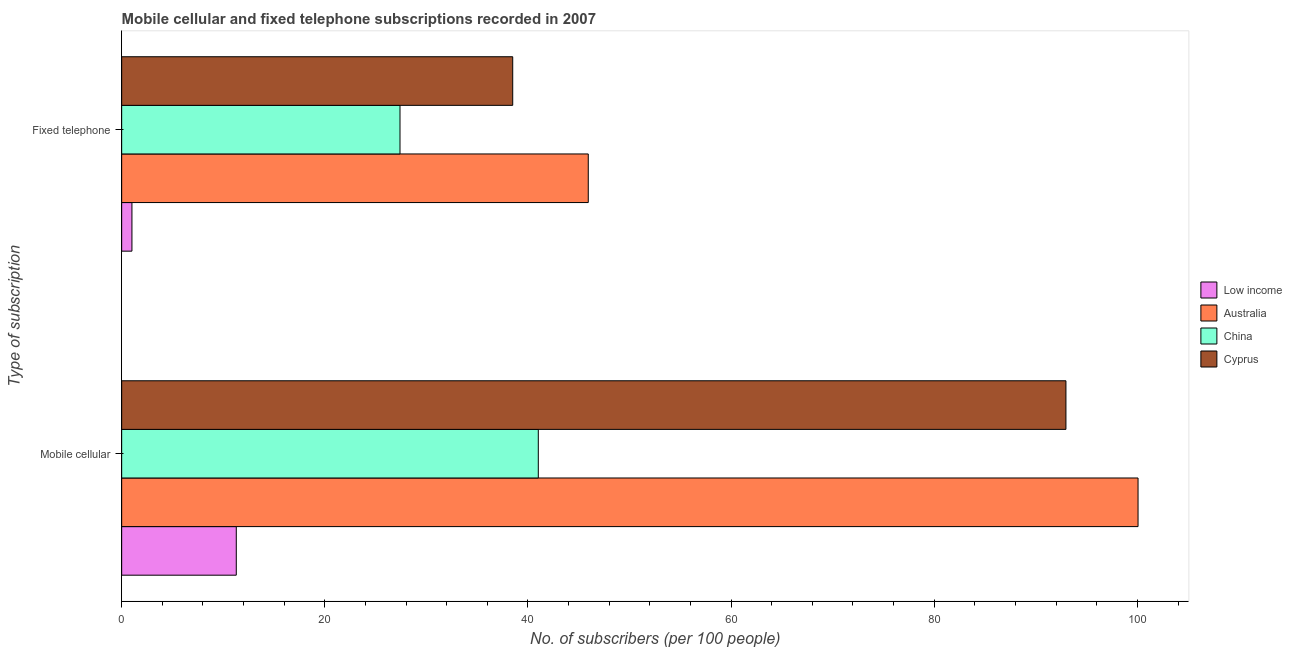How many different coloured bars are there?
Offer a very short reply. 4. How many groups of bars are there?
Provide a succinct answer. 2. Are the number of bars per tick equal to the number of legend labels?
Offer a very short reply. Yes. Are the number of bars on each tick of the Y-axis equal?
Ensure brevity in your answer.  Yes. How many bars are there on the 2nd tick from the top?
Provide a succinct answer. 4. How many bars are there on the 2nd tick from the bottom?
Your answer should be very brief. 4. What is the label of the 2nd group of bars from the top?
Your answer should be very brief. Mobile cellular. What is the number of mobile cellular subscribers in Low income?
Give a very brief answer. 11.28. Across all countries, what is the maximum number of mobile cellular subscribers?
Your answer should be very brief. 100.06. Across all countries, what is the minimum number of fixed telephone subscribers?
Offer a terse response. 1.01. In which country was the number of mobile cellular subscribers maximum?
Your answer should be very brief. Australia. In which country was the number of fixed telephone subscribers minimum?
Provide a short and direct response. Low income. What is the total number of fixed telephone subscribers in the graph?
Your answer should be compact. 112.85. What is the difference between the number of fixed telephone subscribers in Australia and that in Cyprus?
Offer a terse response. 7.44. What is the difference between the number of fixed telephone subscribers in China and the number of mobile cellular subscribers in Low income?
Your answer should be very brief. 16.12. What is the average number of fixed telephone subscribers per country?
Your answer should be very brief. 28.21. What is the difference between the number of mobile cellular subscribers and number of fixed telephone subscribers in Australia?
Provide a short and direct response. 54.13. In how many countries, is the number of mobile cellular subscribers greater than 80 ?
Your answer should be compact. 2. What is the ratio of the number of fixed telephone subscribers in Australia to that in Cyprus?
Ensure brevity in your answer.  1.19. In how many countries, is the number of mobile cellular subscribers greater than the average number of mobile cellular subscribers taken over all countries?
Your answer should be compact. 2. What does the 4th bar from the top in Fixed telephone represents?
Your answer should be compact. Low income. What does the 1st bar from the bottom in Mobile cellular represents?
Offer a terse response. Low income. How many countries are there in the graph?
Offer a very short reply. 4. What is the difference between two consecutive major ticks on the X-axis?
Your answer should be compact. 20. Are the values on the major ticks of X-axis written in scientific E-notation?
Ensure brevity in your answer.  No. Does the graph contain any zero values?
Make the answer very short. No. Where does the legend appear in the graph?
Your response must be concise. Center right. What is the title of the graph?
Keep it short and to the point. Mobile cellular and fixed telephone subscriptions recorded in 2007. Does "Seychelles" appear as one of the legend labels in the graph?
Provide a succinct answer. No. What is the label or title of the X-axis?
Keep it short and to the point. No. of subscribers (per 100 people). What is the label or title of the Y-axis?
Offer a terse response. Type of subscription. What is the No. of subscribers (per 100 people) in Low income in Mobile cellular?
Make the answer very short. 11.28. What is the No. of subscribers (per 100 people) in Australia in Mobile cellular?
Give a very brief answer. 100.06. What is the No. of subscribers (per 100 people) of China in Mobile cellular?
Offer a terse response. 41.02. What is the No. of subscribers (per 100 people) in Cyprus in Mobile cellular?
Ensure brevity in your answer.  92.97. What is the No. of subscribers (per 100 people) in Low income in Fixed telephone?
Give a very brief answer. 1.01. What is the No. of subscribers (per 100 people) in Australia in Fixed telephone?
Your answer should be very brief. 45.94. What is the No. of subscribers (per 100 people) in China in Fixed telephone?
Ensure brevity in your answer.  27.4. What is the No. of subscribers (per 100 people) of Cyprus in Fixed telephone?
Offer a very short reply. 38.5. Across all Type of subscription, what is the maximum No. of subscribers (per 100 people) in Low income?
Offer a terse response. 11.28. Across all Type of subscription, what is the maximum No. of subscribers (per 100 people) of Australia?
Your answer should be compact. 100.06. Across all Type of subscription, what is the maximum No. of subscribers (per 100 people) of China?
Give a very brief answer. 41.02. Across all Type of subscription, what is the maximum No. of subscribers (per 100 people) in Cyprus?
Offer a very short reply. 92.97. Across all Type of subscription, what is the minimum No. of subscribers (per 100 people) in Low income?
Your answer should be very brief. 1.01. Across all Type of subscription, what is the minimum No. of subscribers (per 100 people) in Australia?
Give a very brief answer. 45.94. Across all Type of subscription, what is the minimum No. of subscribers (per 100 people) of China?
Make the answer very short. 27.4. Across all Type of subscription, what is the minimum No. of subscribers (per 100 people) in Cyprus?
Your answer should be very brief. 38.5. What is the total No. of subscribers (per 100 people) of Low income in the graph?
Your response must be concise. 12.29. What is the total No. of subscribers (per 100 people) of Australia in the graph?
Keep it short and to the point. 146. What is the total No. of subscribers (per 100 people) of China in the graph?
Ensure brevity in your answer.  68.42. What is the total No. of subscribers (per 100 people) of Cyprus in the graph?
Provide a short and direct response. 131.46. What is the difference between the No. of subscribers (per 100 people) of Low income in Mobile cellular and that in Fixed telephone?
Make the answer very short. 10.27. What is the difference between the No. of subscribers (per 100 people) in Australia in Mobile cellular and that in Fixed telephone?
Offer a very short reply. 54.13. What is the difference between the No. of subscribers (per 100 people) of China in Mobile cellular and that in Fixed telephone?
Keep it short and to the point. 13.61. What is the difference between the No. of subscribers (per 100 people) of Cyprus in Mobile cellular and that in Fixed telephone?
Offer a terse response. 54.47. What is the difference between the No. of subscribers (per 100 people) in Low income in Mobile cellular and the No. of subscribers (per 100 people) in Australia in Fixed telephone?
Your answer should be very brief. -34.65. What is the difference between the No. of subscribers (per 100 people) of Low income in Mobile cellular and the No. of subscribers (per 100 people) of China in Fixed telephone?
Make the answer very short. -16.12. What is the difference between the No. of subscribers (per 100 people) in Low income in Mobile cellular and the No. of subscribers (per 100 people) in Cyprus in Fixed telephone?
Your response must be concise. -27.22. What is the difference between the No. of subscribers (per 100 people) in Australia in Mobile cellular and the No. of subscribers (per 100 people) in China in Fixed telephone?
Make the answer very short. 72.66. What is the difference between the No. of subscribers (per 100 people) in Australia in Mobile cellular and the No. of subscribers (per 100 people) in Cyprus in Fixed telephone?
Your answer should be compact. 61.57. What is the difference between the No. of subscribers (per 100 people) of China in Mobile cellular and the No. of subscribers (per 100 people) of Cyprus in Fixed telephone?
Ensure brevity in your answer.  2.52. What is the average No. of subscribers (per 100 people) in Low income per Type of subscription?
Your answer should be compact. 6.15. What is the average No. of subscribers (per 100 people) in Australia per Type of subscription?
Keep it short and to the point. 73. What is the average No. of subscribers (per 100 people) in China per Type of subscription?
Provide a short and direct response. 34.21. What is the average No. of subscribers (per 100 people) in Cyprus per Type of subscription?
Offer a terse response. 65.73. What is the difference between the No. of subscribers (per 100 people) in Low income and No. of subscribers (per 100 people) in Australia in Mobile cellular?
Your response must be concise. -88.78. What is the difference between the No. of subscribers (per 100 people) of Low income and No. of subscribers (per 100 people) of China in Mobile cellular?
Your answer should be compact. -29.73. What is the difference between the No. of subscribers (per 100 people) in Low income and No. of subscribers (per 100 people) in Cyprus in Mobile cellular?
Give a very brief answer. -81.68. What is the difference between the No. of subscribers (per 100 people) in Australia and No. of subscribers (per 100 people) in China in Mobile cellular?
Provide a succinct answer. 59.05. What is the difference between the No. of subscribers (per 100 people) in Australia and No. of subscribers (per 100 people) in Cyprus in Mobile cellular?
Make the answer very short. 7.1. What is the difference between the No. of subscribers (per 100 people) in China and No. of subscribers (per 100 people) in Cyprus in Mobile cellular?
Your answer should be very brief. -51.95. What is the difference between the No. of subscribers (per 100 people) in Low income and No. of subscribers (per 100 people) in Australia in Fixed telephone?
Your response must be concise. -44.93. What is the difference between the No. of subscribers (per 100 people) of Low income and No. of subscribers (per 100 people) of China in Fixed telephone?
Provide a succinct answer. -26.39. What is the difference between the No. of subscribers (per 100 people) in Low income and No. of subscribers (per 100 people) in Cyprus in Fixed telephone?
Make the answer very short. -37.49. What is the difference between the No. of subscribers (per 100 people) of Australia and No. of subscribers (per 100 people) of China in Fixed telephone?
Your answer should be compact. 18.54. What is the difference between the No. of subscribers (per 100 people) in Australia and No. of subscribers (per 100 people) in Cyprus in Fixed telephone?
Make the answer very short. 7.44. What is the difference between the No. of subscribers (per 100 people) in China and No. of subscribers (per 100 people) in Cyprus in Fixed telephone?
Offer a very short reply. -11.1. What is the ratio of the No. of subscribers (per 100 people) in Low income in Mobile cellular to that in Fixed telephone?
Offer a very short reply. 11.16. What is the ratio of the No. of subscribers (per 100 people) in Australia in Mobile cellular to that in Fixed telephone?
Make the answer very short. 2.18. What is the ratio of the No. of subscribers (per 100 people) of China in Mobile cellular to that in Fixed telephone?
Your answer should be compact. 1.5. What is the ratio of the No. of subscribers (per 100 people) of Cyprus in Mobile cellular to that in Fixed telephone?
Your answer should be very brief. 2.41. What is the difference between the highest and the second highest No. of subscribers (per 100 people) in Low income?
Give a very brief answer. 10.27. What is the difference between the highest and the second highest No. of subscribers (per 100 people) in Australia?
Make the answer very short. 54.13. What is the difference between the highest and the second highest No. of subscribers (per 100 people) of China?
Your answer should be compact. 13.61. What is the difference between the highest and the second highest No. of subscribers (per 100 people) in Cyprus?
Provide a succinct answer. 54.47. What is the difference between the highest and the lowest No. of subscribers (per 100 people) of Low income?
Give a very brief answer. 10.27. What is the difference between the highest and the lowest No. of subscribers (per 100 people) in Australia?
Give a very brief answer. 54.13. What is the difference between the highest and the lowest No. of subscribers (per 100 people) of China?
Keep it short and to the point. 13.61. What is the difference between the highest and the lowest No. of subscribers (per 100 people) in Cyprus?
Your answer should be very brief. 54.47. 